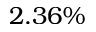<formula> <loc_0><loc_0><loc_500><loc_500>2 . 3 6 \%</formula> 